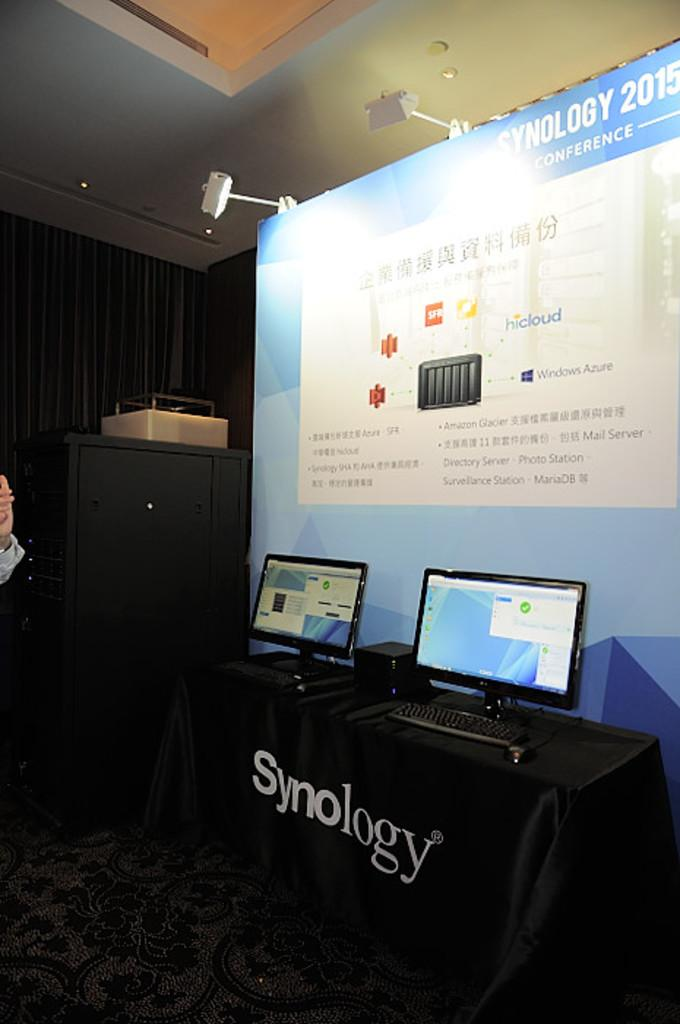<image>
Summarize the visual content of the image. An advertisement board of Synology 2015 Conference with a table of two laptops on it setup in front of the advertisement board. 